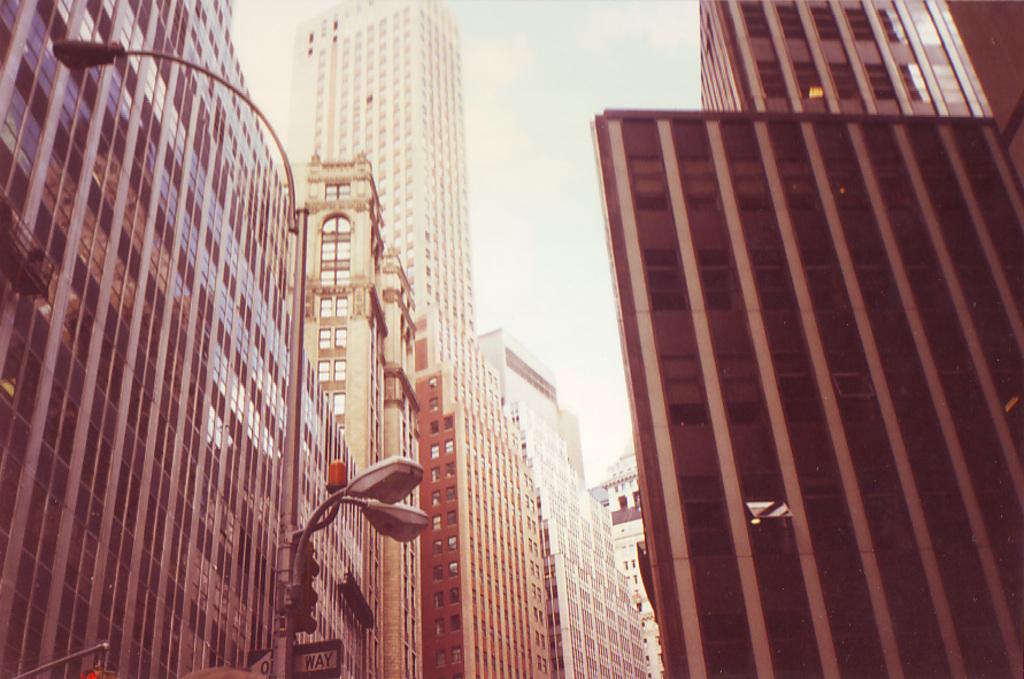What sign is under the street light?
Make the answer very short. One way. 